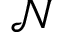<formula> <loc_0><loc_0><loc_500><loc_500>\mathcal { N }</formula> 